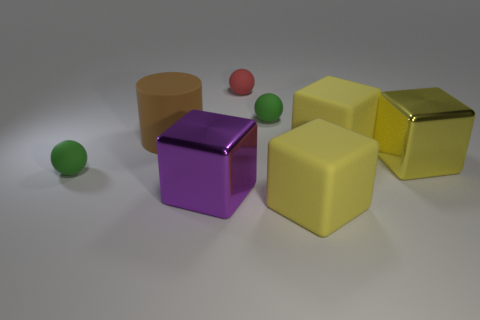What color is the big object that is left of the purple shiny object?
Offer a very short reply. Brown. Does the brown thing have the same material as the tiny sphere to the left of the big brown cylinder?
Your response must be concise. Yes. What is the material of the purple thing?
Your answer should be compact. Metal. There is another object that is the same material as the big purple thing; what shape is it?
Your answer should be compact. Cube. How many other objects are there of the same shape as the big brown object?
Your answer should be compact. 0. There is a purple shiny block; what number of matte things are behind it?
Give a very brief answer. 5. There is a red thing to the right of the cylinder; is its size the same as the green ball on the right side of the brown thing?
Offer a very short reply. Yes. How many other objects are there of the same size as the brown cylinder?
Your answer should be compact. 4. There is a small green ball behind the green ball in front of the green rubber object to the right of the tiny red matte sphere; what is its material?
Provide a short and direct response. Rubber. Is the size of the purple metal block the same as the green rubber object behind the large brown matte cylinder?
Your answer should be very brief. No. 